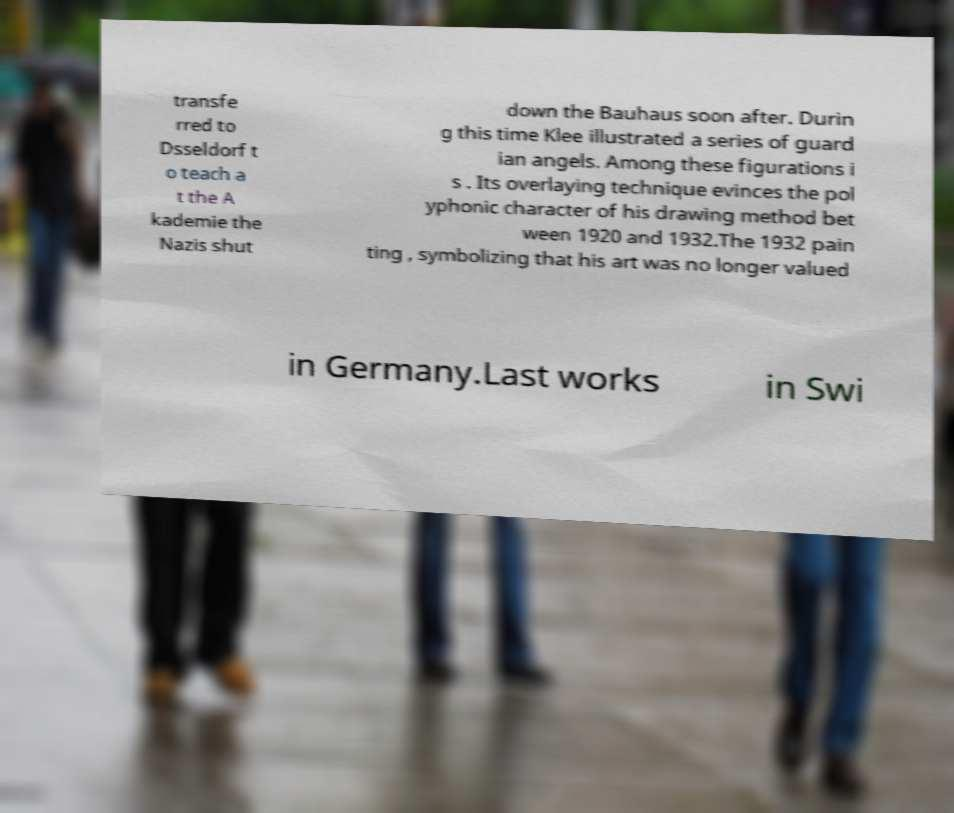What messages or text are displayed in this image? I need them in a readable, typed format. transfe rred to Dsseldorf t o teach a t the A kademie the Nazis shut down the Bauhaus soon after. Durin g this time Klee illustrated a series of guard ian angels. Among these figurations i s . Its overlaying technique evinces the pol yphonic character of his drawing method bet ween 1920 and 1932.The 1932 pain ting , symbolizing that his art was no longer valued in Germany.Last works in Swi 